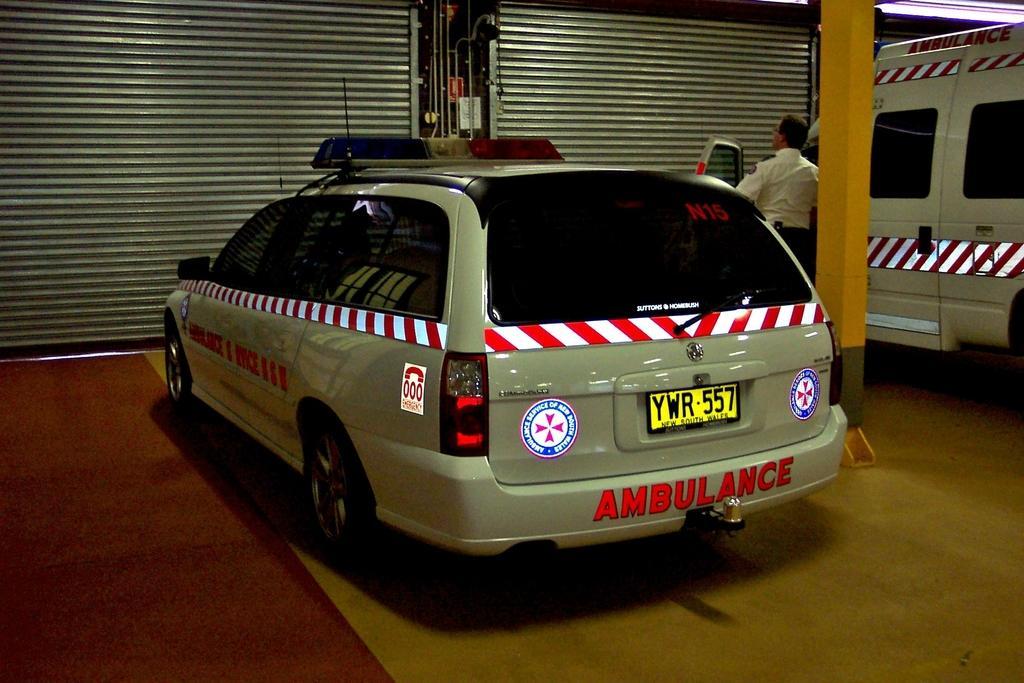Could you give a brief overview of what you see in this image? In this image, we can see few vehicles. At the bottom, there is a floor. Background we can see shutters, rods, pillars. Here a person is standing near the vehicle. 